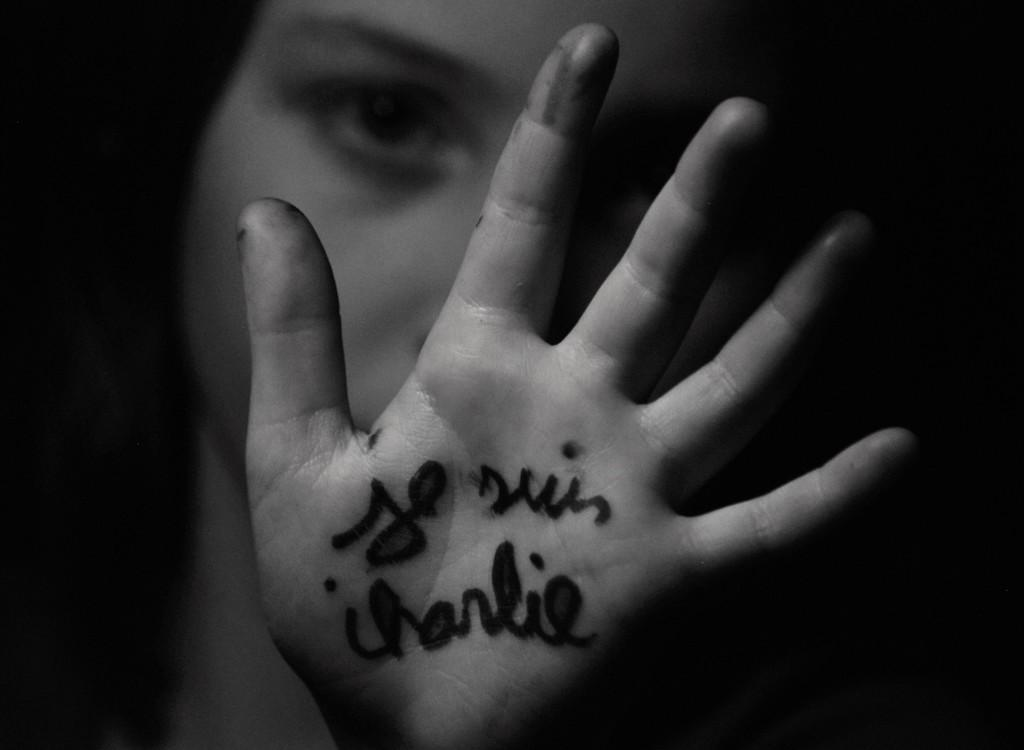Who is the main subject in the image? There is a woman in the image. What is the woman doing with her hand? The woman is showing her hand. Is there any text or symbols on the woman's hand? Yes, there is writing on the woman's hand. What type of coil can be seen wrapped around the woman's hand in the image? There is no coil present on the woman's hand in the image. How does the writing on the woman's hand move in the image? The writing on the woman's hand does not move in the image; it is stationary. 